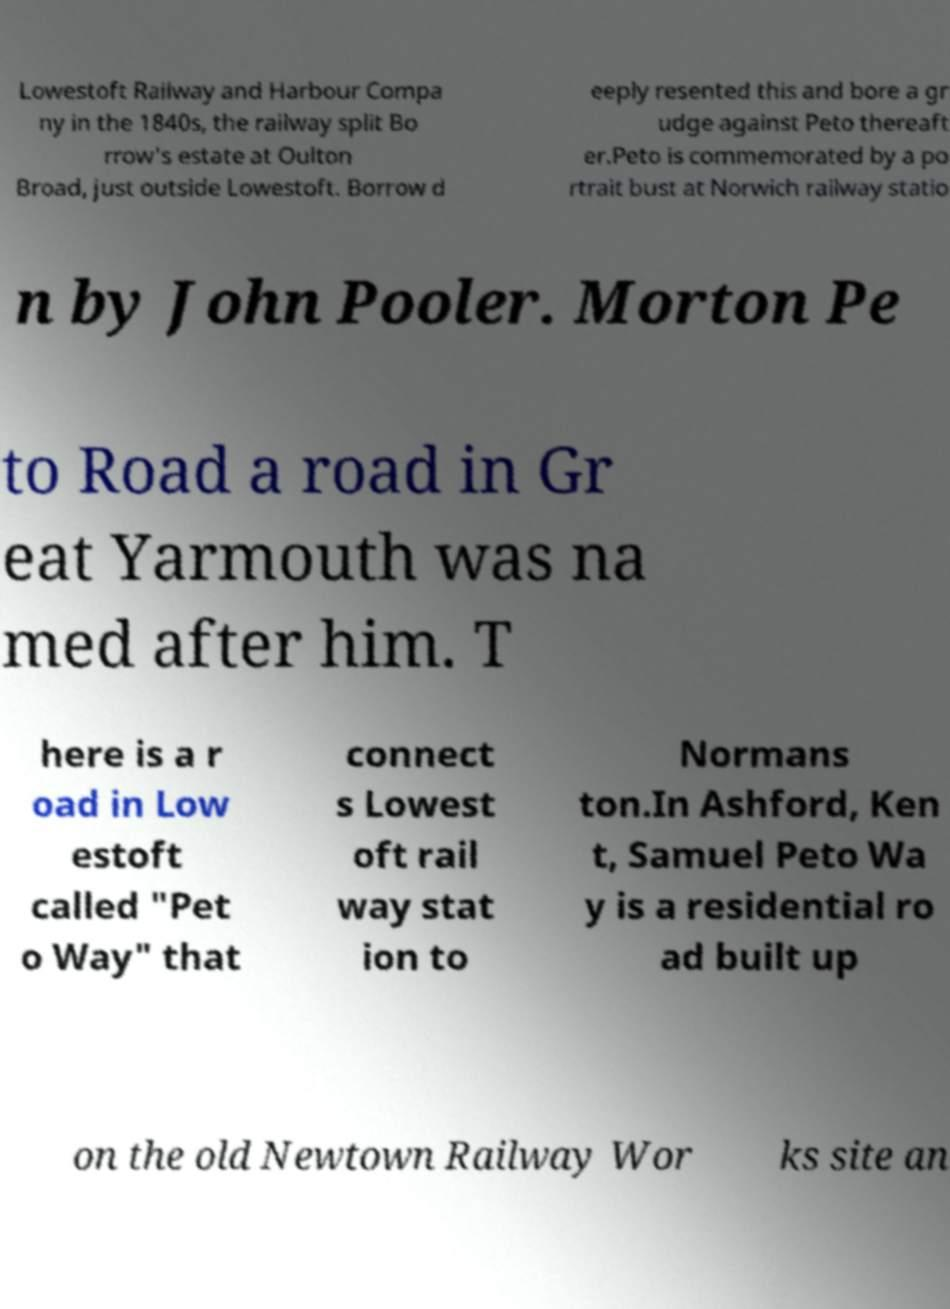Can you read and provide the text displayed in the image?This photo seems to have some interesting text. Can you extract and type it out for me? Lowestoft Railway and Harbour Compa ny in the 1840s, the railway split Bo rrow's estate at Oulton Broad, just outside Lowestoft. Borrow d eeply resented this and bore a gr udge against Peto thereaft er.Peto is commemorated by a po rtrait bust at Norwich railway statio n by John Pooler. Morton Pe to Road a road in Gr eat Yarmouth was na med after him. T here is a r oad in Low estoft called "Pet o Way" that connect s Lowest oft rail way stat ion to Normans ton.In Ashford, Ken t, Samuel Peto Wa y is a residential ro ad built up on the old Newtown Railway Wor ks site an 